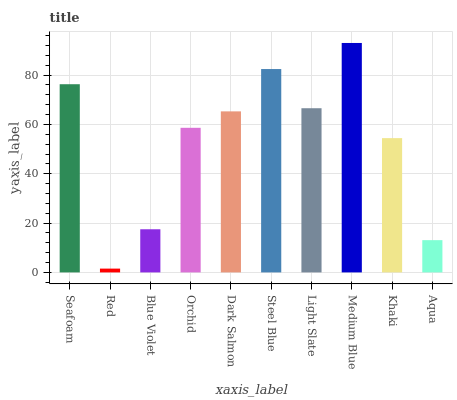Is Red the minimum?
Answer yes or no. Yes. Is Medium Blue the maximum?
Answer yes or no. Yes. Is Blue Violet the minimum?
Answer yes or no. No. Is Blue Violet the maximum?
Answer yes or no. No. Is Blue Violet greater than Red?
Answer yes or no. Yes. Is Red less than Blue Violet?
Answer yes or no. Yes. Is Red greater than Blue Violet?
Answer yes or no. No. Is Blue Violet less than Red?
Answer yes or no. No. Is Dark Salmon the high median?
Answer yes or no. Yes. Is Orchid the low median?
Answer yes or no. Yes. Is Red the high median?
Answer yes or no. No. Is Medium Blue the low median?
Answer yes or no. No. 